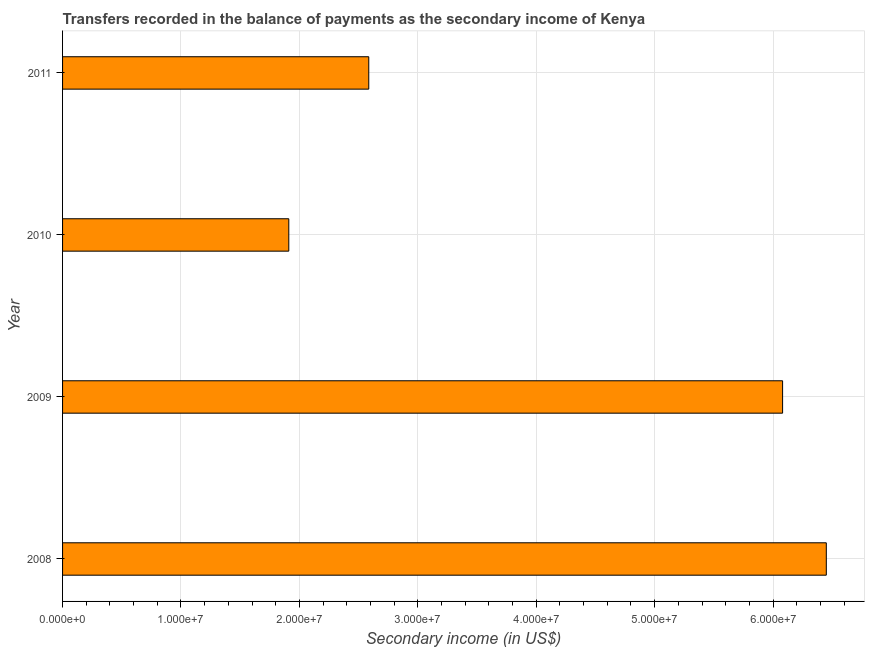What is the title of the graph?
Your answer should be compact. Transfers recorded in the balance of payments as the secondary income of Kenya. What is the label or title of the X-axis?
Offer a terse response. Secondary income (in US$). What is the label or title of the Y-axis?
Provide a succinct answer. Year. What is the amount of secondary income in 2010?
Make the answer very short. 1.91e+07. Across all years, what is the maximum amount of secondary income?
Your answer should be compact. 6.45e+07. Across all years, what is the minimum amount of secondary income?
Your answer should be compact. 1.91e+07. What is the sum of the amount of secondary income?
Give a very brief answer. 1.70e+08. What is the difference between the amount of secondary income in 2008 and 2009?
Your answer should be compact. 3.69e+06. What is the average amount of secondary income per year?
Your answer should be compact. 4.26e+07. What is the median amount of secondary income?
Make the answer very short. 4.33e+07. What is the ratio of the amount of secondary income in 2008 to that in 2011?
Give a very brief answer. 2.49. Is the amount of secondary income in 2010 less than that in 2011?
Your answer should be compact. Yes. What is the difference between the highest and the second highest amount of secondary income?
Your answer should be compact. 3.69e+06. What is the difference between the highest and the lowest amount of secondary income?
Give a very brief answer. 4.54e+07. What is the Secondary income (in US$) in 2008?
Give a very brief answer. 6.45e+07. What is the Secondary income (in US$) of 2009?
Keep it short and to the point. 6.08e+07. What is the Secondary income (in US$) in 2010?
Ensure brevity in your answer.  1.91e+07. What is the Secondary income (in US$) in 2011?
Offer a terse response. 2.59e+07. What is the difference between the Secondary income (in US$) in 2008 and 2009?
Provide a short and direct response. 3.69e+06. What is the difference between the Secondary income (in US$) in 2008 and 2010?
Provide a succinct answer. 4.54e+07. What is the difference between the Secondary income (in US$) in 2008 and 2011?
Offer a terse response. 3.86e+07. What is the difference between the Secondary income (in US$) in 2009 and 2010?
Your response must be concise. 4.17e+07. What is the difference between the Secondary income (in US$) in 2009 and 2011?
Your answer should be very brief. 3.49e+07. What is the difference between the Secondary income (in US$) in 2010 and 2011?
Make the answer very short. -6.75e+06. What is the ratio of the Secondary income (in US$) in 2008 to that in 2009?
Ensure brevity in your answer.  1.06. What is the ratio of the Secondary income (in US$) in 2008 to that in 2010?
Your response must be concise. 3.38. What is the ratio of the Secondary income (in US$) in 2008 to that in 2011?
Offer a terse response. 2.49. What is the ratio of the Secondary income (in US$) in 2009 to that in 2010?
Your answer should be very brief. 3.18. What is the ratio of the Secondary income (in US$) in 2009 to that in 2011?
Your response must be concise. 2.35. What is the ratio of the Secondary income (in US$) in 2010 to that in 2011?
Make the answer very short. 0.74. 